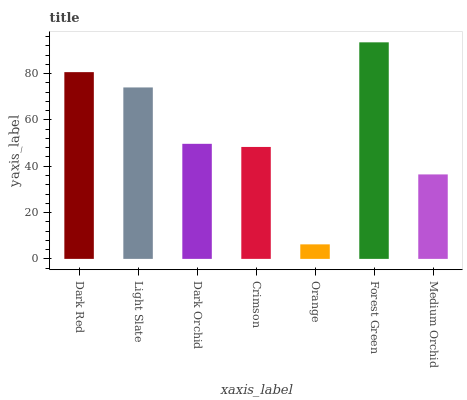Is Light Slate the minimum?
Answer yes or no. No. Is Light Slate the maximum?
Answer yes or no. No. Is Dark Red greater than Light Slate?
Answer yes or no. Yes. Is Light Slate less than Dark Red?
Answer yes or no. Yes. Is Light Slate greater than Dark Red?
Answer yes or no. No. Is Dark Red less than Light Slate?
Answer yes or no. No. Is Dark Orchid the high median?
Answer yes or no. Yes. Is Dark Orchid the low median?
Answer yes or no. Yes. Is Forest Green the high median?
Answer yes or no. No. Is Crimson the low median?
Answer yes or no. No. 